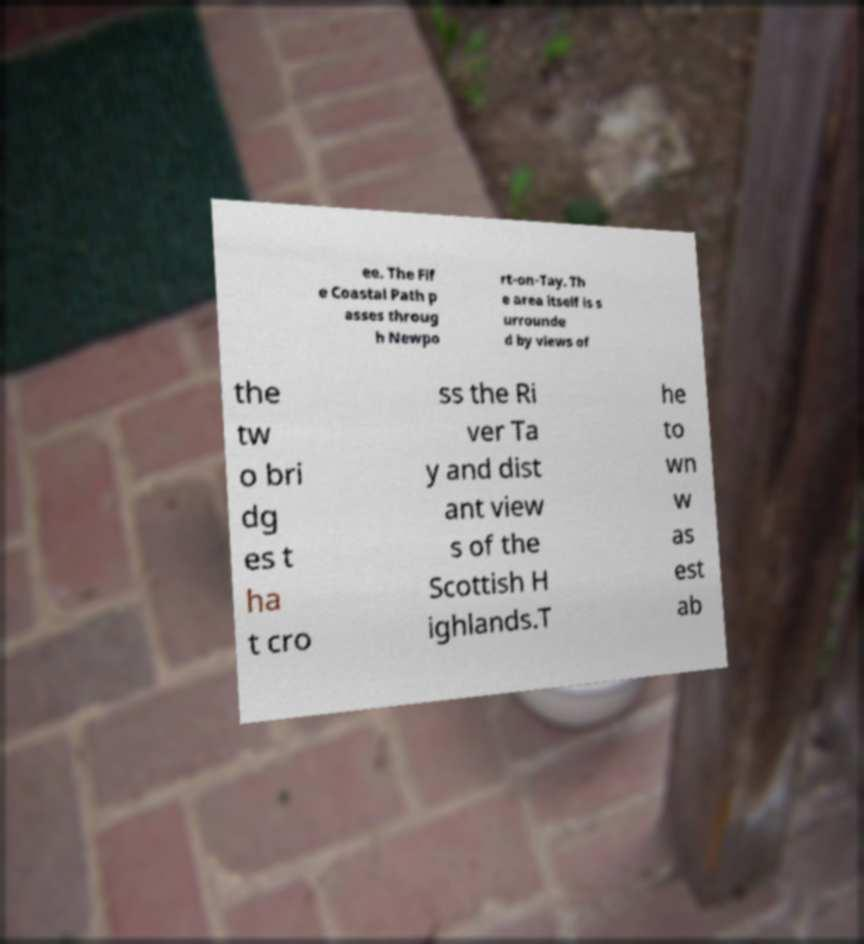For documentation purposes, I need the text within this image transcribed. Could you provide that? ee. The Fif e Coastal Path p asses throug h Newpo rt-on-Tay. Th e area itself is s urrounde d by views of the tw o bri dg es t ha t cro ss the Ri ver Ta y and dist ant view s of the Scottish H ighlands.T he to wn w as est ab 